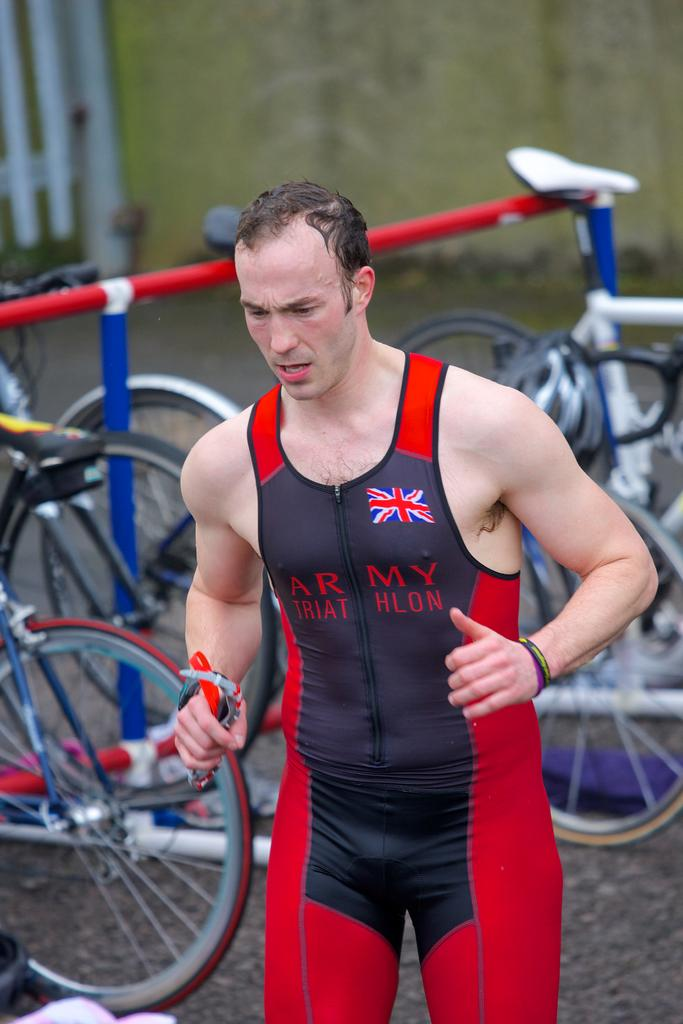<image>
Summarize the visual content of the image. The man is promoting the army triathlon for another country. 